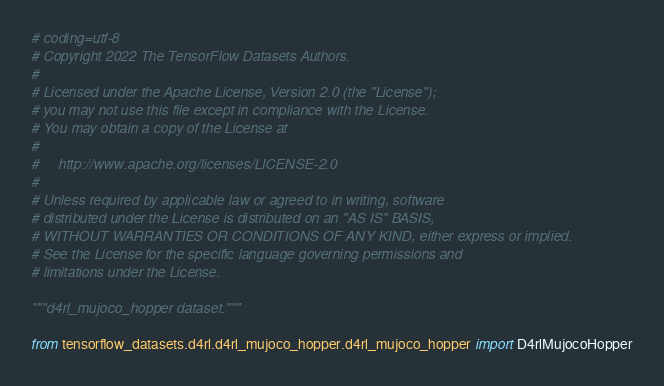<code> <loc_0><loc_0><loc_500><loc_500><_Python_># coding=utf-8
# Copyright 2022 The TensorFlow Datasets Authors.
#
# Licensed under the Apache License, Version 2.0 (the "License");
# you may not use this file except in compliance with the License.
# You may obtain a copy of the License at
#
#     http://www.apache.org/licenses/LICENSE-2.0
#
# Unless required by applicable law or agreed to in writing, software
# distributed under the License is distributed on an "AS IS" BASIS,
# WITHOUT WARRANTIES OR CONDITIONS OF ANY KIND, either express or implied.
# See the License for the specific language governing permissions and
# limitations under the License.

"""d4rl_mujoco_hopper dataset."""

from tensorflow_datasets.d4rl.d4rl_mujoco_hopper.d4rl_mujoco_hopper import D4rlMujocoHopper
</code> 